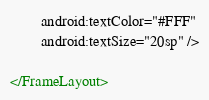Convert code to text. <code><loc_0><loc_0><loc_500><loc_500><_XML_>        android:textColor="#FFF"
        android:textSize="20sp" />

</FrameLayout></code> 